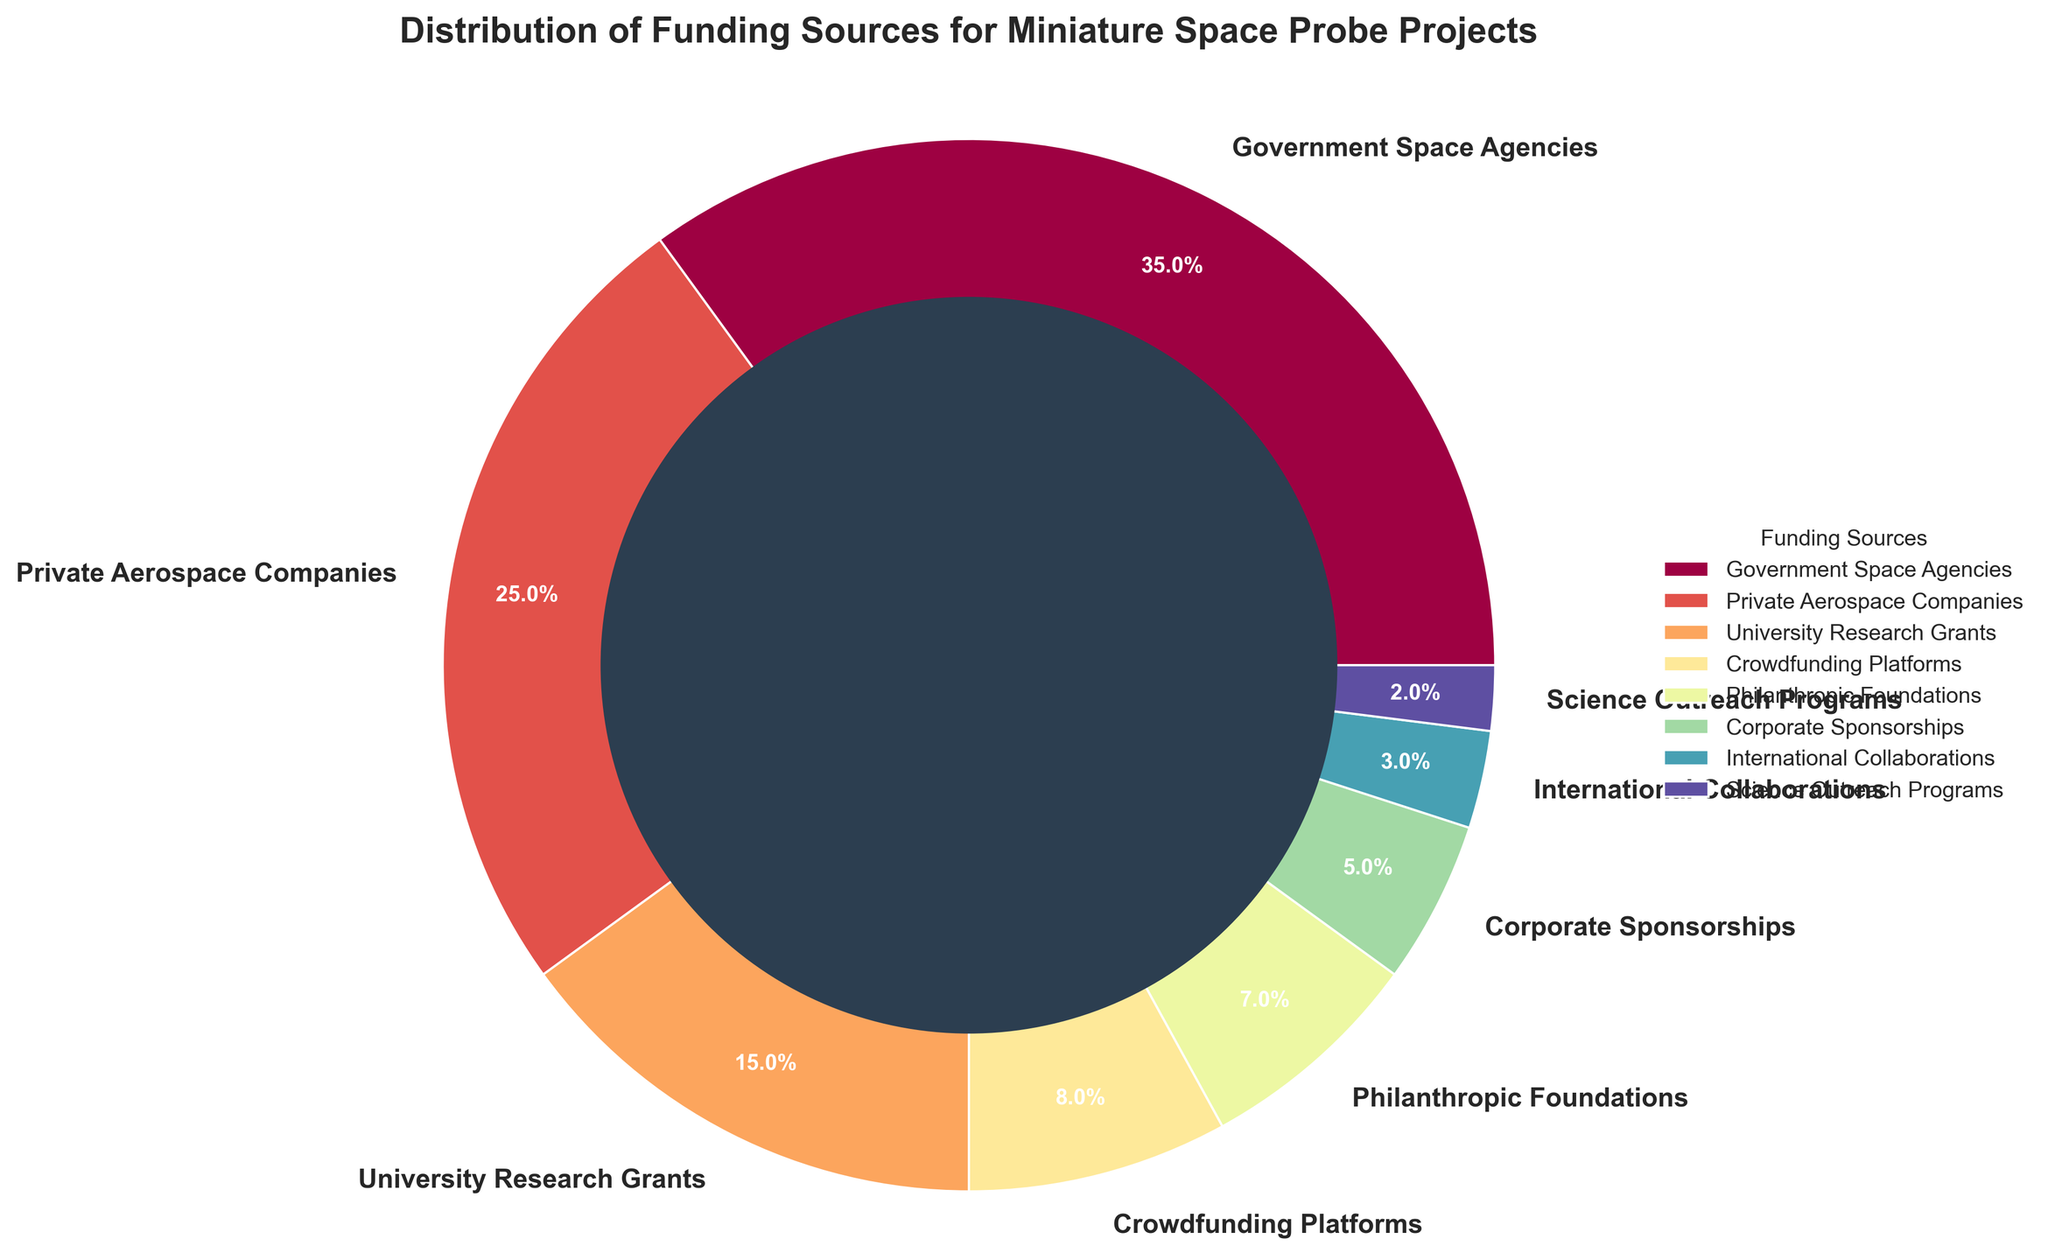What is the largest funding source for miniature space probe projects? The pie chart indicates that "Government Space Agencies" has the largest segment, representing 35%.
Answer: Government Space Agencies Which two categories together make up over 50% of the total funding? "Government Space Agencies" (35%) and "Private Aerospace Companies" (25%) together contribute 35% + 25% = 60%, which is over 50%.
Answer: Government Space Agencies and Private Aerospace Companies How much more percentage does "University Research Grants" have compared to "Corporate Sponsorships"? "University Research Grants" have 15% while "Corporate Sponsorships" have 5%. Therefore, the difference is 15% - 5% = 10%.
Answer: 10% What is the combined funding percentage from "Crowdfunding Platforms" and "Philanthropic Foundations"? "Crowdfunding Platforms" contribute 8%, and "Philanthropic Foundations" contribute 7%. So, their combined funding is 8% + 7% = 15%.
Answer: 15% Are there any funding sources that contribute less than 5%? If so, which ones? From the pie chart, "International Collaborations" (3%) and "Science Outreach Programs" (2%) both contribute less than 5%.
Answer: International Collaborations and Science Outreach Programs Which funding source contributes the least? The pie chart shows that "Science Outreach Programs" contribute 2%, which is the smallest percentage.
Answer: Science Outreach Programs How do the contributions of "Private Aerospace Companies" and "Philanthropic Foundations" compare? "Private Aerospace Companies" contribute 25%, while "Philanthropic Foundations" contribute 7%, making "Private Aerospace Companies" the larger contributor.
Answer: Private Aerospace Companies contribute more What is the percentage difference between the largest and the smallest funding sources? The largest funding source is "Government Space Agencies" with 35%, and the smallest is "Science Outreach Programs" with 2%. The difference is 35% - 2% = 33%.
Answer: 33% What visual feature distinguishes the contribution of "Government Space Agencies" from others? The "Government Space Agencies" section is the largest slice in the pie chart, making it visually the most dominant.
Answer: Largest slice How does the combined funding percentage from non-government sources compare to government sources? Non-government sources add up to 65% (100% - 35% from "Government Space Agencies"). Government sources are 35%. Therefore, non-government sources contribute more.
Answer: Non-government sources contribute more 